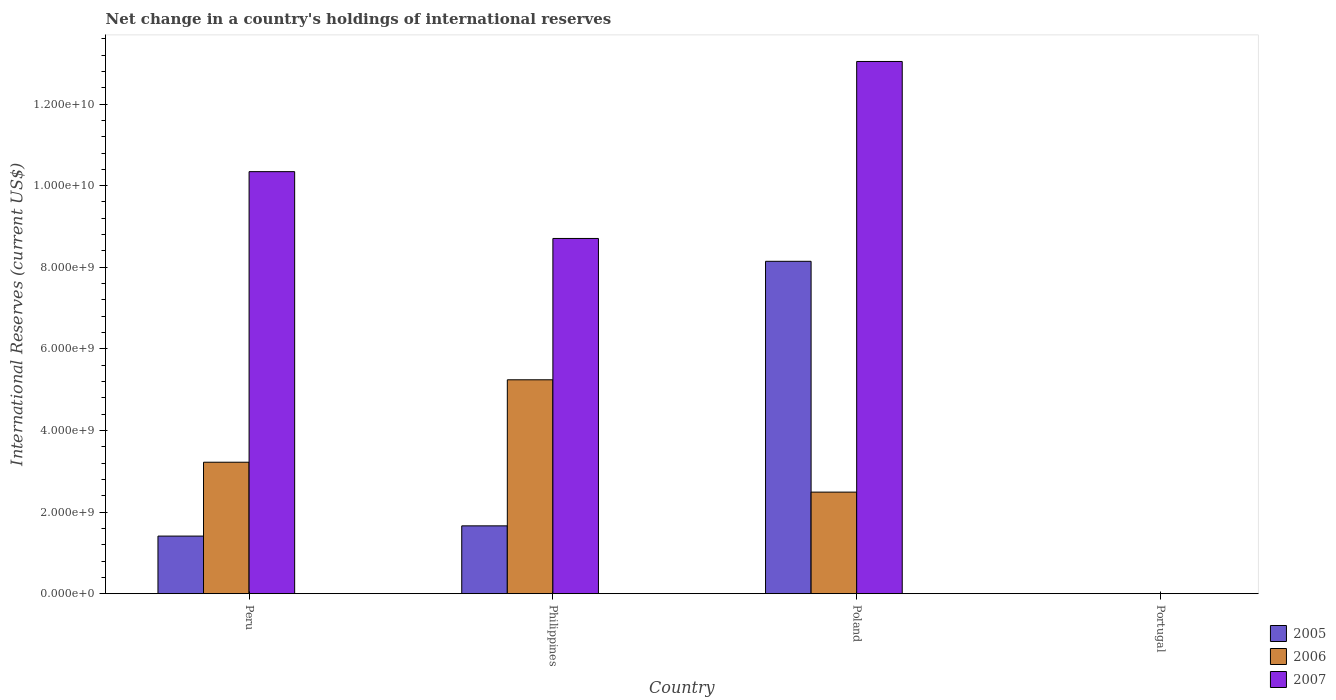How many different coloured bars are there?
Make the answer very short. 3. How many bars are there on the 3rd tick from the left?
Offer a very short reply. 3. How many bars are there on the 3rd tick from the right?
Provide a short and direct response. 3. What is the label of the 2nd group of bars from the left?
Provide a succinct answer. Philippines. In how many cases, is the number of bars for a given country not equal to the number of legend labels?
Offer a terse response. 1. What is the international reserves in 2007 in Poland?
Offer a very short reply. 1.30e+1. Across all countries, what is the maximum international reserves in 2007?
Give a very brief answer. 1.30e+1. In which country was the international reserves in 2006 maximum?
Provide a succinct answer. Philippines. What is the total international reserves in 2005 in the graph?
Make the answer very short. 1.12e+1. What is the difference between the international reserves in 2006 in Peru and that in Philippines?
Make the answer very short. -2.02e+09. What is the difference between the international reserves in 2005 in Portugal and the international reserves in 2006 in Poland?
Your answer should be very brief. -2.49e+09. What is the average international reserves in 2006 per country?
Ensure brevity in your answer.  2.74e+09. What is the difference between the international reserves of/in 2006 and international reserves of/in 2007 in Philippines?
Provide a short and direct response. -3.46e+09. In how many countries, is the international reserves in 2007 greater than 11600000000 US$?
Provide a succinct answer. 1. What is the ratio of the international reserves in 2005 in Peru to that in Poland?
Your response must be concise. 0.17. Is the international reserves in 2005 in Peru less than that in Poland?
Give a very brief answer. Yes. What is the difference between the highest and the second highest international reserves in 2007?
Your answer should be compact. 4.34e+09. What is the difference between the highest and the lowest international reserves in 2007?
Give a very brief answer. 1.30e+1. Is the sum of the international reserves in 2005 in Peru and Philippines greater than the maximum international reserves in 2007 across all countries?
Provide a succinct answer. No. Is it the case that in every country, the sum of the international reserves in 2006 and international reserves in 2005 is greater than the international reserves in 2007?
Provide a succinct answer. No. Are all the bars in the graph horizontal?
Offer a very short reply. No. How many countries are there in the graph?
Offer a very short reply. 4. What is the difference between two consecutive major ticks on the Y-axis?
Ensure brevity in your answer.  2.00e+09. Are the values on the major ticks of Y-axis written in scientific E-notation?
Offer a terse response. Yes. Does the graph contain any zero values?
Your answer should be very brief. Yes. Does the graph contain grids?
Give a very brief answer. No. Where does the legend appear in the graph?
Ensure brevity in your answer.  Bottom right. How many legend labels are there?
Keep it short and to the point. 3. What is the title of the graph?
Keep it short and to the point. Net change in a country's holdings of international reserves. Does "1985" appear as one of the legend labels in the graph?
Offer a terse response. No. What is the label or title of the Y-axis?
Keep it short and to the point. International Reserves (current US$). What is the International Reserves (current US$) of 2005 in Peru?
Your response must be concise. 1.41e+09. What is the International Reserves (current US$) in 2006 in Peru?
Ensure brevity in your answer.  3.22e+09. What is the International Reserves (current US$) in 2007 in Peru?
Ensure brevity in your answer.  1.03e+1. What is the International Reserves (current US$) in 2005 in Philippines?
Ensure brevity in your answer.  1.66e+09. What is the International Reserves (current US$) in 2006 in Philippines?
Ensure brevity in your answer.  5.24e+09. What is the International Reserves (current US$) in 2007 in Philippines?
Ensure brevity in your answer.  8.71e+09. What is the International Reserves (current US$) in 2005 in Poland?
Give a very brief answer. 8.15e+09. What is the International Reserves (current US$) of 2006 in Poland?
Make the answer very short. 2.49e+09. What is the International Reserves (current US$) in 2007 in Poland?
Provide a short and direct response. 1.30e+1. Across all countries, what is the maximum International Reserves (current US$) in 2005?
Provide a short and direct response. 8.15e+09. Across all countries, what is the maximum International Reserves (current US$) of 2006?
Ensure brevity in your answer.  5.24e+09. Across all countries, what is the maximum International Reserves (current US$) of 2007?
Provide a succinct answer. 1.30e+1. Across all countries, what is the minimum International Reserves (current US$) in 2006?
Provide a short and direct response. 0. Across all countries, what is the minimum International Reserves (current US$) of 2007?
Give a very brief answer. 0. What is the total International Reserves (current US$) of 2005 in the graph?
Your answer should be very brief. 1.12e+1. What is the total International Reserves (current US$) in 2006 in the graph?
Your answer should be compact. 1.10e+1. What is the total International Reserves (current US$) in 2007 in the graph?
Give a very brief answer. 3.21e+1. What is the difference between the International Reserves (current US$) of 2005 in Peru and that in Philippines?
Your answer should be compact. -2.51e+08. What is the difference between the International Reserves (current US$) of 2006 in Peru and that in Philippines?
Give a very brief answer. -2.02e+09. What is the difference between the International Reserves (current US$) of 2007 in Peru and that in Philippines?
Provide a succinct answer. 1.64e+09. What is the difference between the International Reserves (current US$) of 2005 in Peru and that in Poland?
Make the answer very short. -6.73e+09. What is the difference between the International Reserves (current US$) in 2006 in Peru and that in Poland?
Your response must be concise. 7.33e+08. What is the difference between the International Reserves (current US$) in 2007 in Peru and that in Poland?
Ensure brevity in your answer.  -2.70e+09. What is the difference between the International Reserves (current US$) in 2005 in Philippines and that in Poland?
Ensure brevity in your answer.  -6.48e+09. What is the difference between the International Reserves (current US$) of 2006 in Philippines and that in Poland?
Your response must be concise. 2.75e+09. What is the difference between the International Reserves (current US$) in 2007 in Philippines and that in Poland?
Offer a very short reply. -4.34e+09. What is the difference between the International Reserves (current US$) of 2005 in Peru and the International Reserves (current US$) of 2006 in Philippines?
Offer a terse response. -3.83e+09. What is the difference between the International Reserves (current US$) in 2005 in Peru and the International Reserves (current US$) in 2007 in Philippines?
Provide a short and direct response. -7.29e+09. What is the difference between the International Reserves (current US$) of 2006 in Peru and the International Reserves (current US$) of 2007 in Philippines?
Provide a short and direct response. -5.48e+09. What is the difference between the International Reserves (current US$) in 2005 in Peru and the International Reserves (current US$) in 2006 in Poland?
Make the answer very short. -1.08e+09. What is the difference between the International Reserves (current US$) of 2005 in Peru and the International Reserves (current US$) of 2007 in Poland?
Provide a short and direct response. -1.16e+1. What is the difference between the International Reserves (current US$) of 2006 in Peru and the International Reserves (current US$) of 2007 in Poland?
Your answer should be very brief. -9.82e+09. What is the difference between the International Reserves (current US$) of 2005 in Philippines and the International Reserves (current US$) of 2006 in Poland?
Your answer should be compact. -8.27e+08. What is the difference between the International Reserves (current US$) in 2005 in Philippines and the International Reserves (current US$) in 2007 in Poland?
Provide a short and direct response. -1.14e+1. What is the difference between the International Reserves (current US$) in 2006 in Philippines and the International Reserves (current US$) in 2007 in Poland?
Give a very brief answer. -7.80e+09. What is the average International Reserves (current US$) in 2005 per country?
Give a very brief answer. 2.80e+09. What is the average International Reserves (current US$) in 2006 per country?
Offer a terse response. 2.74e+09. What is the average International Reserves (current US$) in 2007 per country?
Your answer should be very brief. 8.02e+09. What is the difference between the International Reserves (current US$) of 2005 and International Reserves (current US$) of 2006 in Peru?
Ensure brevity in your answer.  -1.81e+09. What is the difference between the International Reserves (current US$) in 2005 and International Reserves (current US$) in 2007 in Peru?
Ensure brevity in your answer.  -8.93e+09. What is the difference between the International Reserves (current US$) in 2006 and International Reserves (current US$) in 2007 in Peru?
Offer a terse response. -7.12e+09. What is the difference between the International Reserves (current US$) in 2005 and International Reserves (current US$) in 2006 in Philippines?
Make the answer very short. -3.58e+09. What is the difference between the International Reserves (current US$) in 2005 and International Reserves (current US$) in 2007 in Philippines?
Your answer should be very brief. -7.04e+09. What is the difference between the International Reserves (current US$) in 2006 and International Reserves (current US$) in 2007 in Philippines?
Offer a terse response. -3.46e+09. What is the difference between the International Reserves (current US$) in 2005 and International Reserves (current US$) in 2006 in Poland?
Give a very brief answer. 5.66e+09. What is the difference between the International Reserves (current US$) in 2005 and International Reserves (current US$) in 2007 in Poland?
Your answer should be very brief. -4.90e+09. What is the difference between the International Reserves (current US$) in 2006 and International Reserves (current US$) in 2007 in Poland?
Your answer should be compact. -1.06e+1. What is the ratio of the International Reserves (current US$) in 2005 in Peru to that in Philippines?
Your answer should be very brief. 0.85. What is the ratio of the International Reserves (current US$) in 2006 in Peru to that in Philippines?
Offer a terse response. 0.61. What is the ratio of the International Reserves (current US$) in 2007 in Peru to that in Philippines?
Give a very brief answer. 1.19. What is the ratio of the International Reserves (current US$) of 2005 in Peru to that in Poland?
Give a very brief answer. 0.17. What is the ratio of the International Reserves (current US$) in 2006 in Peru to that in Poland?
Offer a terse response. 1.29. What is the ratio of the International Reserves (current US$) in 2007 in Peru to that in Poland?
Ensure brevity in your answer.  0.79. What is the ratio of the International Reserves (current US$) of 2005 in Philippines to that in Poland?
Your response must be concise. 0.2. What is the ratio of the International Reserves (current US$) in 2006 in Philippines to that in Poland?
Your answer should be compact. 2.11. What is the ratio of the International Reserves (current US$) in 2007 in Philippines to that in Poland?
Offer a very short reply. 0.67. What is the difference between the highest and the second highest International Reserves (current US$) in 2005?
Provide a short and direct response. 6.48e+09. What is the difference between the highest and the second highest International Reserves (current US$) of 2006?
Make the answer very short. 2.02e+09. What is the difference between the highest and the second highest International Reserves (current US$) in 2007?
Make the answer very short. 2.70e+09. What is the difference between the highest and the lowest International Reserves (current US$) of 2005?
Offer a terse response. 8.15e+09. What is the difference between the highest and the lowest International Reserves (current US$) of 2006?
Your response must be concise. 5.24e+09. What is the difference between the highest and the lowest International Reserves (current US$) in 2007?
Offer a very short reply. 1.30e+1. 